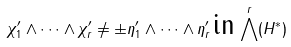Convert formula to latex. <formula><loc_0><loc_0><loc_500><loc_500>\chi _ { 1 } ^ { \prime } \wedge \dots \wedge \chi _ { r } ^ { \prime } \neq \pm \eta _ { 1 } ^ { \prime } \wedge \dots \wedge \eta _ { r } ^ { \prime } \, \text {in} \, \bigwedge ^ { r } ( H ^ { * } )</formula> 